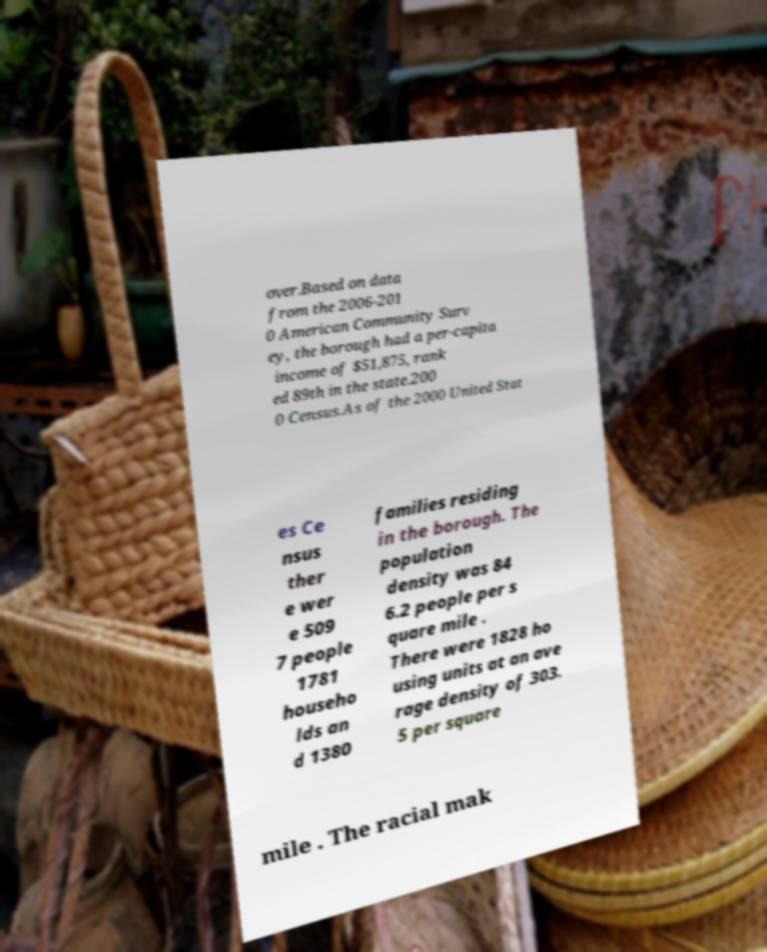What messages or text are displayed in this image? I need them in a readable, typed format. over.Based on data from the 2006-201 0 American Community Surv ey, the borough had a per-capita income of $51,875, rank ed 89th in the state.200 0 Census.As of the 2000 United Stat es Ce nsus ther e wer e 509 7 people 1781 househo lds an d 1380 families residing in the borough. The population density was 84 6.2 people per s quare mile . There were 1828 ho using units at an ave rage density of 303. 5 per square mile . The racial mak 